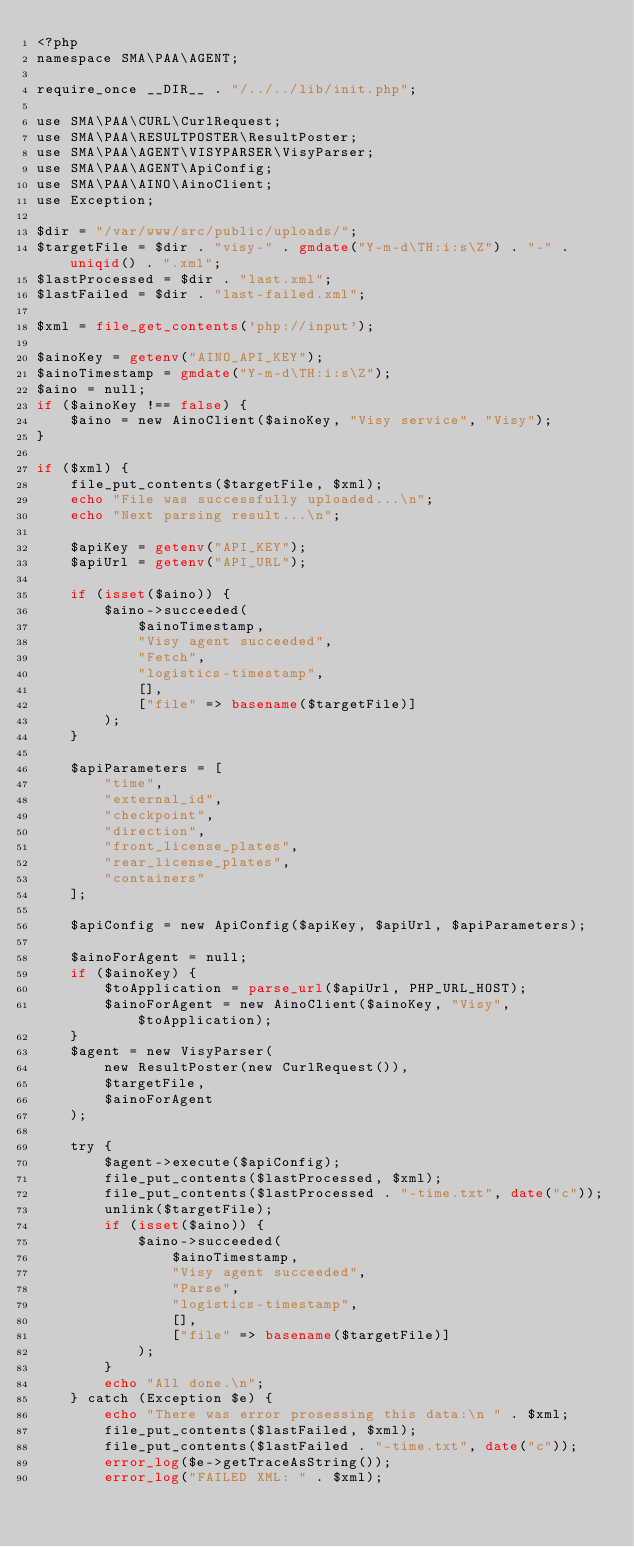Convert code to text. <code><loc_0><loc_0><loc_500><loc_500><_PHP_><?php
namespace SMA\PAA\AGENT;

require_once __DIR__ . "/../../lib/init.php";

use SMA\PAA\CURL\CurlRequest;
use SMA\PAA\RESULTPOSTER\ResultPoster;
use SMA\PAA\AGENT\VISYPARSER\VisyParser;
use SMA\PAA\AGENT\ApiConfig;
use SMA\PAA\AINO\AinoClient;
use Exception;

$dir = "/var/www/src/public/uploads/";
$targetFile = $dir . "visy-" . gmdate("Y-m-d\TH:i:s\Z") . "-" . uniqid() . ".xml";
$lastProcessed = $dir . "last.xml";
$lastFailed = $dir . "last-failed.xml";

$xml = file_get_contents('php://input');

$ainoKey = getenv("AINO_API_KEY");
$ainoTimestamp = gmdate("Y-m-d\TH:i:s\Z");
$aino = null;
if ($ainoKey !== false) {
    $aino = new AinoClient($ainoKey, "Visy service", "Visy");
}

if ($xml) {
    file_put_contents($targetFile, $xml);
    echo "File was successfully uploaded...\n";
    echo "Next parsing result...\n";

    $apiKey = getenv("API_KEY");
    $apiUrl = getenv("API_URL");

    if (isset($aino)) {
        $aino->succeeded(
            $ainoTimestamp,
            "Visy agent succeeded",
            "Fetch",
            "logistics-timestamp",
            [],
            ["file" => basename($targetFile)]
        );
    }

    $apiParameters = [
        "time",
        "external_id",
        "checkpoint",
        "direction",
        "front_license_plates",
        "rear_license_plates",
        "containers"
    ];

    $apiConfig = new ApiConfig($apiKey, $apiUrl, $apiParameters);

    $ainoForAgent = null;
    if ($ainoKey) {
        $toApplication = parse_url($apiUrl, PHP_URL_HOST);
        $ainoForAgent = new AinoClient($ainoKey, "Visy", $toApplication);
    }
    $agent = new VisyParser(
        new ResultPoster(new CurlRequest()),
        $targetFile,
        $ainoForAgent
    );

    try {
        $agent->execute($apiConfig);
        file_put_contents($lastProcessed, $xml);
        file_put_contents($lastProcessed . "-time.txt", date("c"));
        unlink($targetFile);
        if (isset($aino)) {
            $aino->succeeded(
                $ainoTimestamp,
                "Visy agent succeeded",
                "Parse",
                "logistics-timestamp",
                [],
                ["file" => basename($targetFile)]
            );
        }
        echo "All done.\n";
    } catch (Exception $e) {
        echo "There was error prosessing this data:\n " . $xml;
        file_put_contents($lastFailed, $xml);
        file_put_contents($lastFailed . "-time.txt", date("c"));
        error_log($e->getTraceAsString());
        error_log("FAILED XML: " . $xml);</code> 